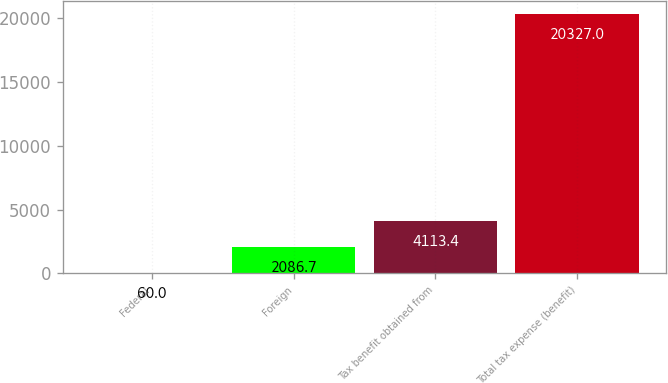Convert chart. <chart><loc_0><loc_0><loc_500><loc_500><bar_chart><fcel>Federal<fcel>Foreign<fcel>Tax benefit obtained from<fcel>Total tax expense (benefit)<nl><fcel>60<fcel>2086.7<fcel>4113.4<fcel>20327<nl></chart> 